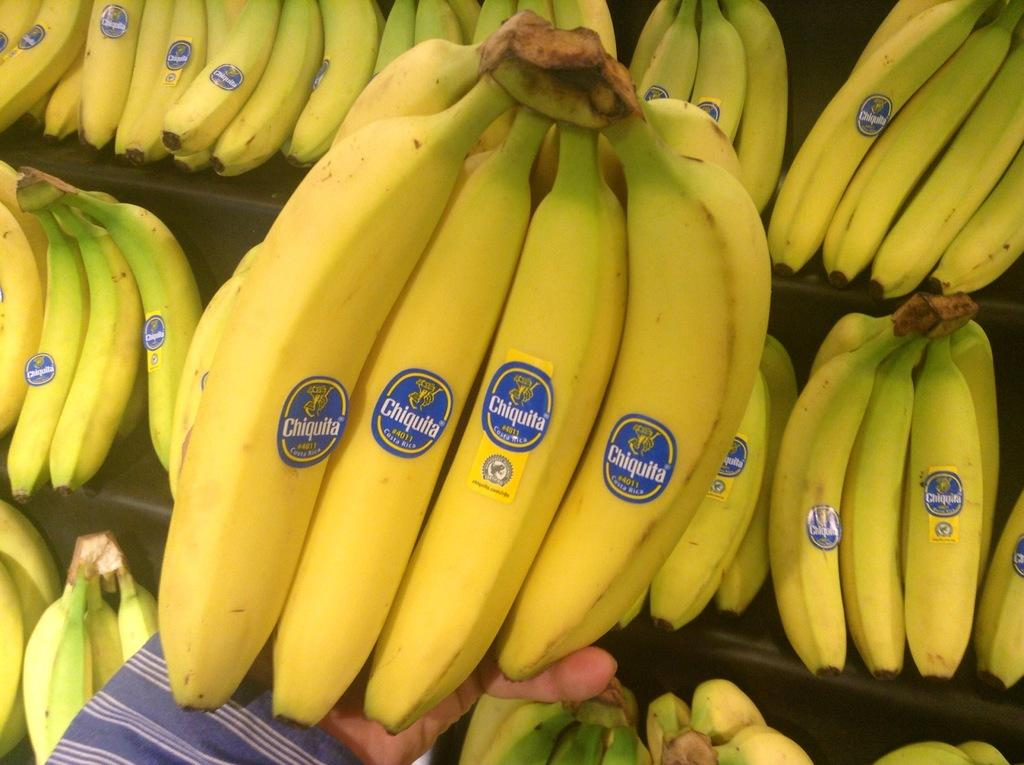What type of fruit is present in the image? There are bananas in the image. What is the person in the image doing with the bananas? A person is holding some bananas in the image. Are there any additional features on the bananas? Yes, the bananas have stickers on them. What information can be found on the stickers? There is writing on the stickers. How many lizards are sitting on the bananas in the image? There are no lizards present in the image; it only features bananas, a person, and stickers. What type of cracker is being eaten with the bananas in the image? There is no cracker present in the image; it only features bananas, a person, and stickers. 